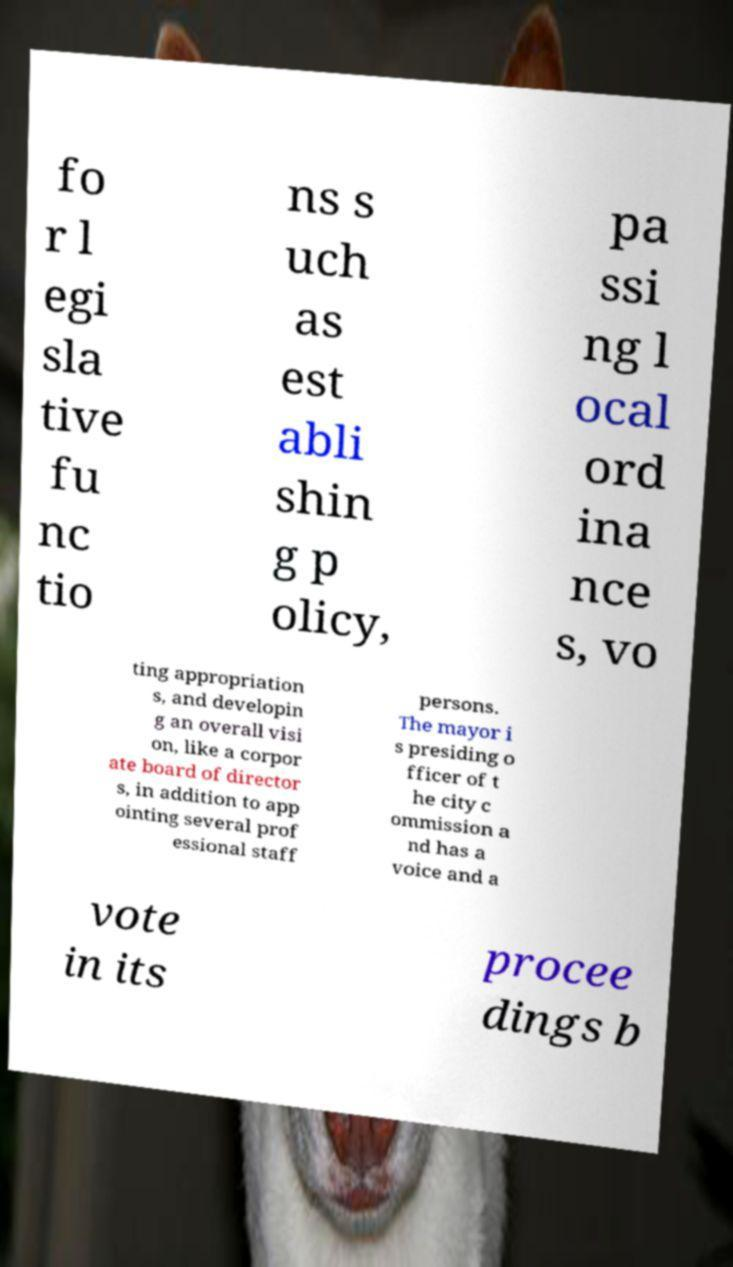Could you extract and type out the text from this image? fo r l egi sla tive fu nc tio ns s uch as est abli shin g p olicy, pa ssi ng l ocal ord ina nce s, vo ting appropriation s, and developin g an overall visi on, like a corpor ate board of director s, in addition to app ointing several prof essional staff persons. The mayor i s presiding o fficer of t he city c ommission a nd has a voice and a vote in its procee dings b 